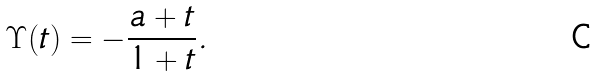Convert formula to latex. <formula><loc_0><loc_0><loc_500><loc_500>\Upsilon ( t ) = - \frac { a + t } { 1 + t } .</formula> 